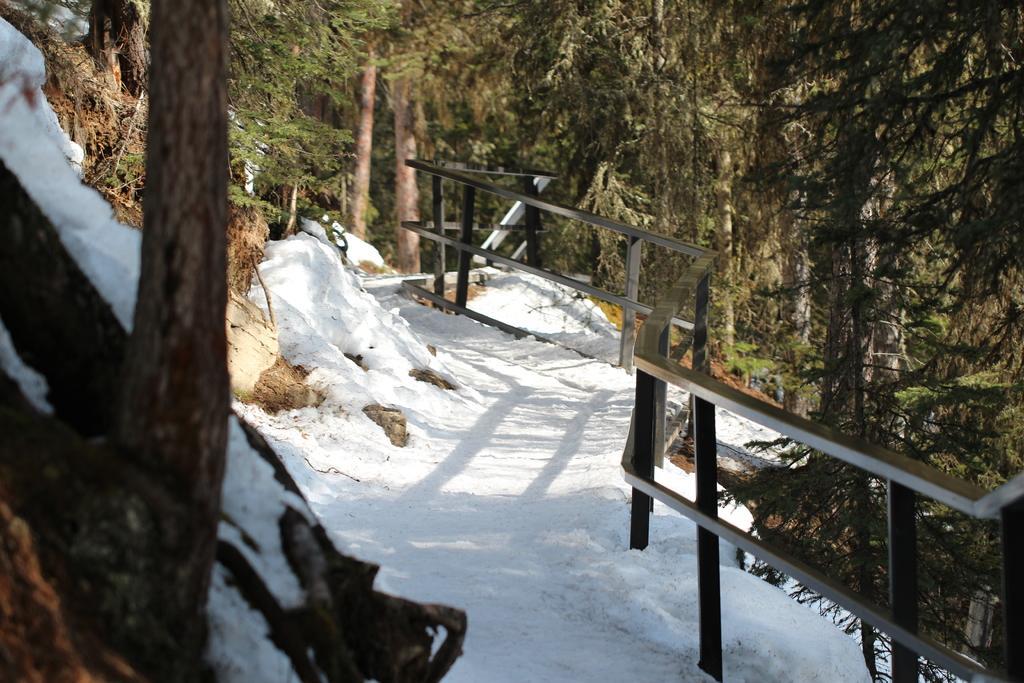Could you give a brief overview of what you see in this image? In the middle there is the snow on the way, these are the green trees in this image. 